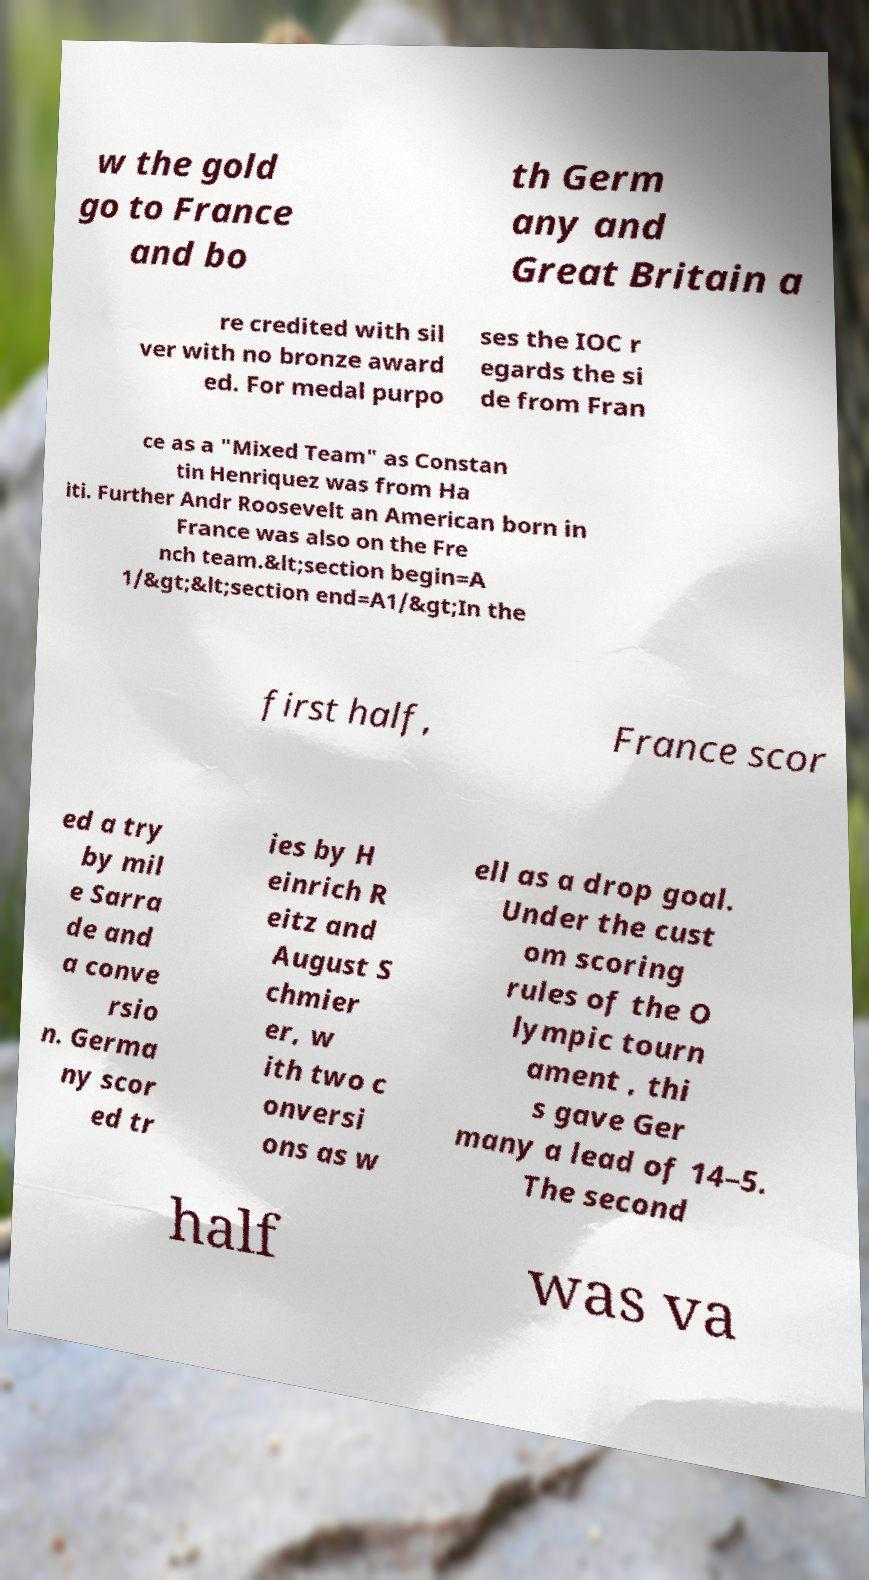Could you assist in decoding the text presented in this image and type it out clearly? w the gold go to France and bo th Germ any and Great Britain a re credited with sil ver with no bronze award ed. For medal purpo ses the IOC r egards the si de from Fran ce as a "Mixed Team" as Constan tin Henriquez was from Ha iti. Further Andr Roosevelt an American born in France was also on the Fre nch team.&lt;section begin=A 1/&gt;&lt;section end=A1/&gt;In the first half, France scor ed a try by mil e Sarra de and a conve rsio n. Germa ny scor ed tr ies by H einrich R eitz and August S chmier er, w ith two c onversi ons as w ell as a drop goal. Under the cust om scoring rules of the O lympic tourn ament , thi s gave Ger many a lead of 14–5. The second half was va 